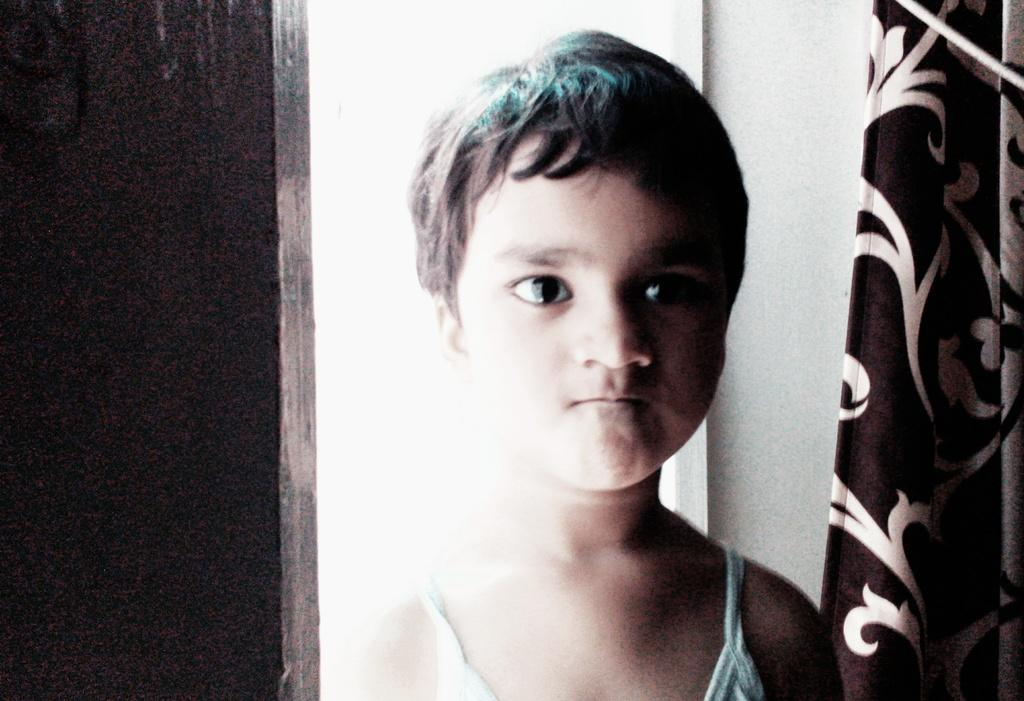What is the main subject of the image? The main subject of the image is a kid. What is the kid wearing? The kid is wearing a blue dress. What is the kid doing in the image? The kid is standing. What can be seen in the right corner of the image? There is a brown and white color curtain in the right corner of the image. What type of nose can be seen on the group of kids in the image? There is no group of kids in the image, only one kid is present. Additionally, the image does not show any noses. 